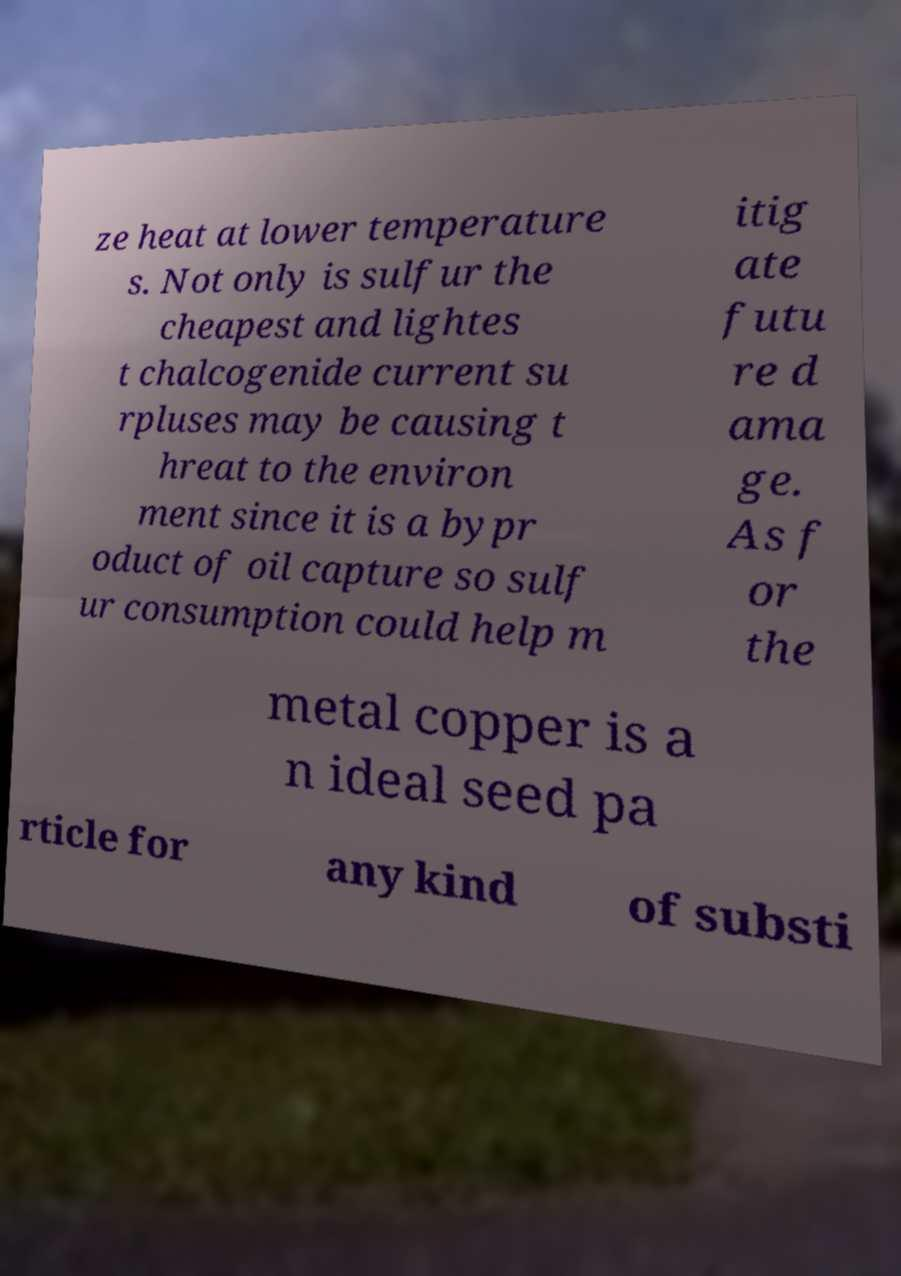Can you read and provide the text displayed in the image?This photo seems to have some interesting text. Can you extract and type it out for me? ze heat at lower temperature s. Not only is sulfur the cheapest and lightes t chalcogenide current su rpluses may be causing t hreat to the environ ment since it is a bypr oduct of oil capture so sulf ur consumption could help m itig ate futu re d ama ge. As f or the metal copper is a n ideal seed pa rticle for any kind of substi 